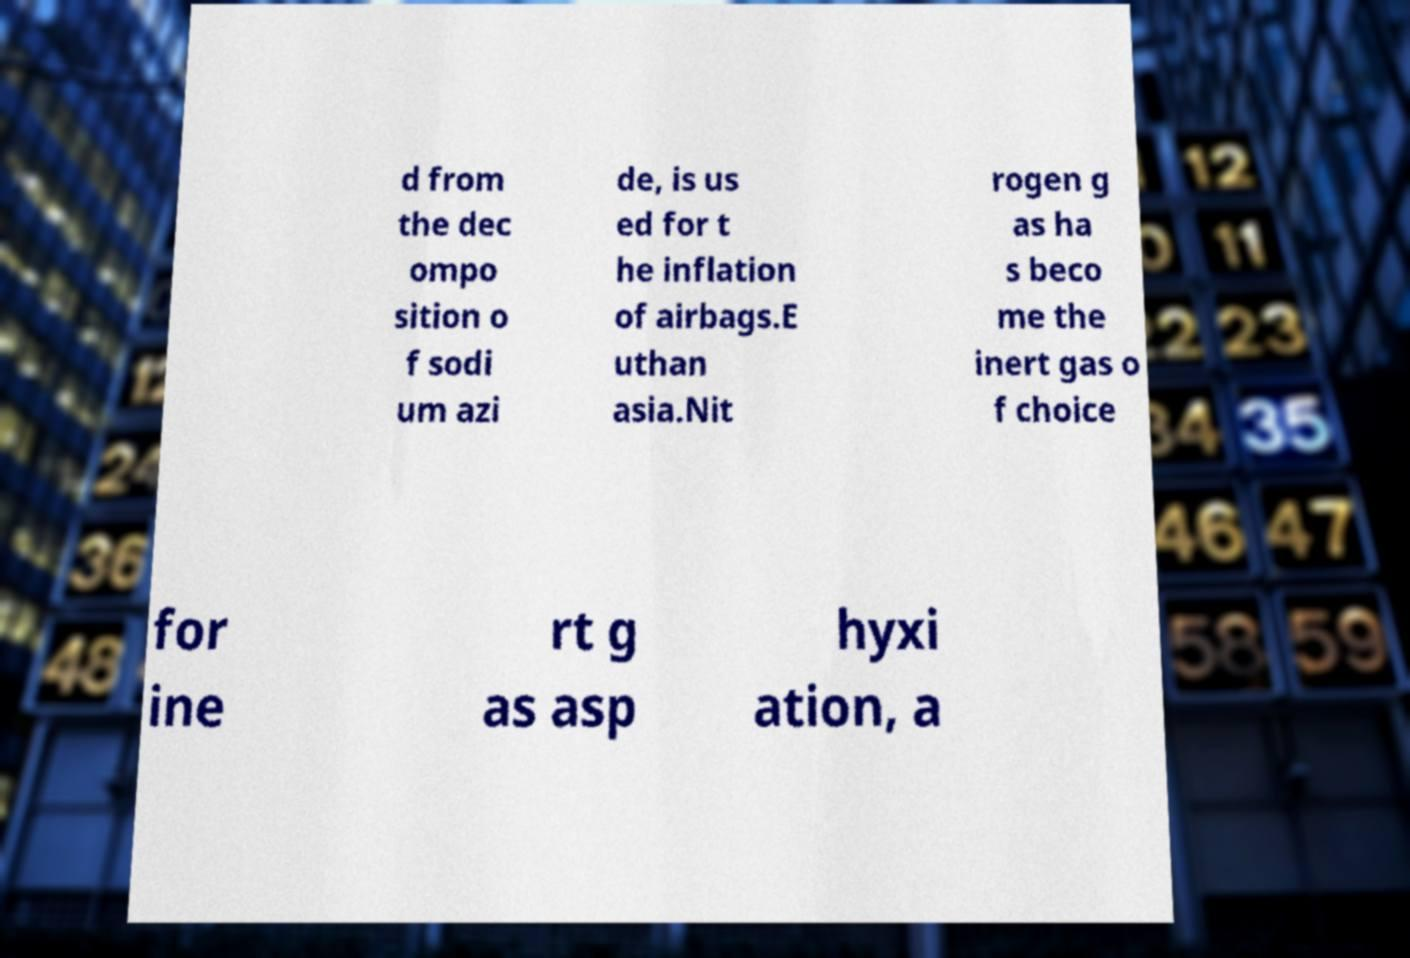Please read and relay the text visible in this image. What does it say? d from the dec ompo sition o f sodi um azi de, is us ed for t he inflation of airbags.E uthan asia.Nit rogen g as ha s beco me the inert gas o f choice for ine rt g as asp hyxi ation, a 